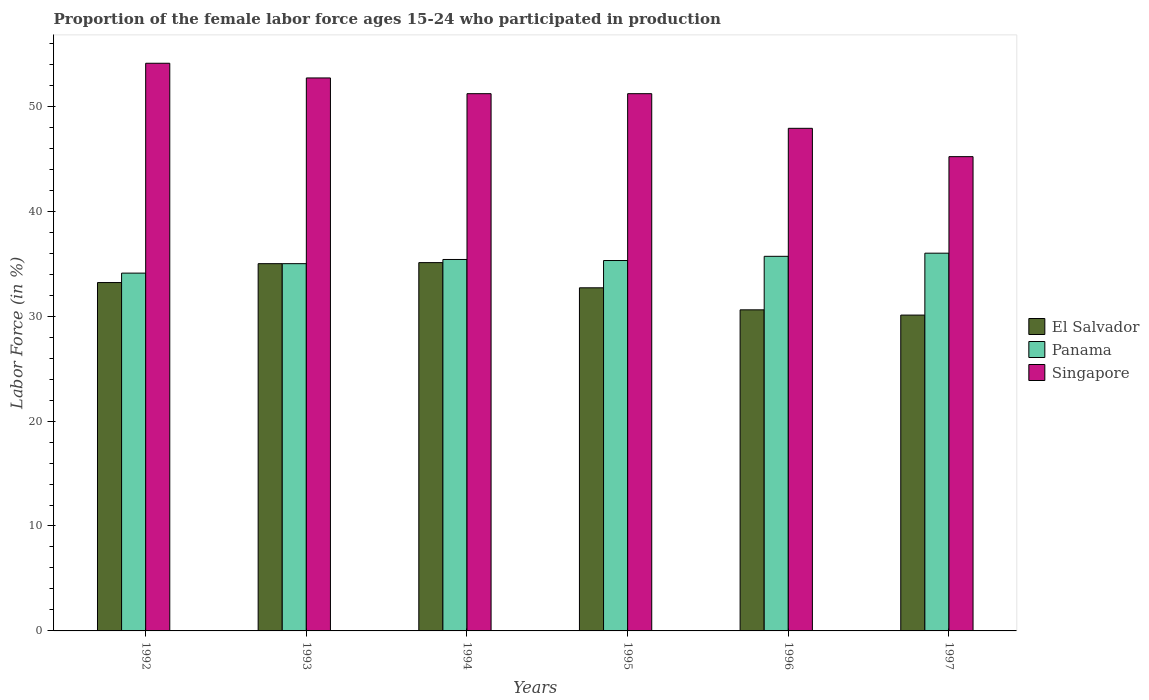How many groups of bars are there?
Keep it short and to the point. 6. How many bars are there on the 3rd tick from the left?
Provide a short and direct response. 3. How many bars are there on the 4th tick from the right?
Make the answer very short. 3. What is the label of the 3rd group of bars from the left?
Offer a very short reply. 1994. In how many cases, is the number of bars for a given year not equal to the number of legend labels?
Give a very brief answer. 0. What is the proportion of the female labor force who participated in production in Panama in 1997?
Your answer should be compact. 36. Across all years, what is the minimum proportion of the female labor force who participated in production in Singapore?
Offer a very short reply. 45.2. In which year was the proportion of the female labor force who participated in production in El Salvador maximum?
Offer a terse response. 1994. What is the total proportion of the female labor force who participated in production in El Salvador in the graph?
Give a very brief answer. 196.7. What is the difference between the proportion of the female labor force who participated in production in El Salvador in 1992 and that in 1994?
Offer a very short reply. -1.9. What is the difference between the proportion of the female labor force who participated in production in El Salvador in 1997 and the proportion of the female labor force who participated in production in Panama in 1996?
Provide a short and direct response. -5.6. What is the average proportion of the female labor force who participated in production in Singapore per year?
Offer a very short reply. 50.38. In the year 1995, what is the difference between the proportion of the female labor force who participated in production in Panama and proportion of the female labor force who participated in production in Singapore?
Your answer should be compact. -15.9. What is the ratio of the proportion of the female labor force who participated in production in El Salvador in 1992 to that in 1995?
Give a very brief answer. 1.02. Is the proportion of the female labor force who participated in production in El Salvador in 1994 less than that in 1995?
Provide a short and direct response. No. Is the difference between the proportion of the female labor force who participated in production in Panama in 1995 and 1997 greater than the difference between the proportion of the female labor force who participated in production in Singapore in 1995 and 1997?
Keep it short and to the point. No. What is the difference between the highest and the second highest proportion of the female labor force who participated in production in El Salvador?
Give a very brief answer. 0.1. What is the difference between the highest and the lowest proportion of the female labor force who participated in production in Singapore?
Your answer should be very brief. 8.9. What does the 2nd bar from the left in 1992 represents?
Your answer should be compact. Panama. What does the 2nd bar from the right in 1992 represents?
Provide a succinct answer. Panama. Are all the bars in the graph horizontal?
Your answer should be compact. No. Does the graph contain grids?
Give a very brief answer. No. Where does the legend appear in the graph?
Your answer should be compact. Center right. How many legend labels are there?
Provide a succinct answer. 3. What is the title of the graph?
Keep it short and to the point. Proportion of the female labor force ages 15-24 who participated in production. What is the label or title of the Y-axis?
Offer a very short reply. Labor Force (in %). What is the Labor Force (in %) in El Salvador in 1992?
Provide a succinct answer. 33.2. What is the Labor Force (in %) of Panama in 1992?
Give a very brief answer. 34.1. What is the Labor Force (in %) in Singapore in 1992?
Make the answer very short. 54.1. What is the Labor Force (in %) in El Salvador in 1993?
Give a very brief answer. 35. What is the Labor Force (in %) in Panama in 1993?
Give a very brief answer. 35. What is the Labor Force (in %) of Singapore in 1993?
Give a very brief answer. 52.7. What is the Labor Force (in %) of El Salvador in 1994?
Your response must be concise. 35.1. What is the Labor Force (in %) of Panama in 1994?
Provide a succinct answer. 35.4. What is the Labor Force (in %) in Singapore in 1994?
Keep it short and to the point. 51.2. What is the Labor Force (in %) in El Salvador in 1995?
Ensure brevity in your answer.  32.7. What is the Labor Force (in %) in Panama in 1995?
Offer a terse response. 35.3. What is the Labor Force (in %) in Singapore in 1995?
Your answer should be compact. 51.2. What is the Labor Force (in %) in El Salvador in 1996?
Give a very brief answer. 30.6. What is the Labor Force (in %) in Panama in 1996?
Make the answer very short. 35.7. What is the Labor Force (in %) in Singapore in 1996?
Your response must be concise. 47.9. What is the Labor Force (in %) in El Salvador in 1997?
Your answer should be compact. 30.1. What is the Labor Force (in %) of Panama in 1997?
Your response must be concise. 36. What is the Labor Force (in %) of Singapore in 1997?
Give a very brief answer. 45.2. Across all years, what is the maximum Labor Force (in %) in El Salvador?
Offer a very short reply. 35.1. Across all years, what is the maximum Labor Force (in %) in Panama?
Keep it short and to the point. 36. Across all years, what is the maximum Labor Force (in %) in Singapore?
Keep it short and to the point. 54.1. Across all years, what is the minimum Labor Force (in %) of El Salvador?
Your answer should be compact. 30.1. Across all years, what is the minimum Labor Force (in %) in Panama?
Ensure brevity in your answer.  34.1. Across all years, what is the minimum Labor Force (in %) in Singapore?
Your answer should be very brief. 45.2. What is the total Labor Force (in %) in El Salvador in the graph?
Make the answer very short. 196.7. What is the total Labor Force (in %) of Panama in the graph?
Keep it short and to the point. 211.5. What is the total Labor Force (in %) of Singapore in the graph?
Your response must be concise. 302.3. What is the difference between the Labor Force (in %) in Panama in 1992 and that in 1993?
Give a very brief answer. -0.9. What is the difference between the Labor Force (in %) in El Salvador in 1992 and that in 1994?
Give a very brief answer. -1.9. What is the difference between the Labor Force (in %) in Panama in 1992 and that in 1995?
Provide a succinct answer. -1.2. What is the difference between the Labor Force (in %) of Singapore in 1992 and that in 1996?
Keep it short and to the point. 6.2. What is the difference between the Labor Force (in %) of El Salvador in 1992 and that in 1997?
Give a very brief answer. 3.1. What is the difference between the Labor Force (in %) in Panama in 1992 and that in 1997?
Provide a short and direct response. -1.9. What is the difference between the Labor Force (in %) in Panama in 1993 and that in 1994?
Ensure brevity in your answer.  -0.4. What is the difference between the Labor Force (in %) in El Salvador in 1993 and that in 1995?
Offer a terse response. 2.3. What is the difference between the Labor Force (in %) of Panama in 1993 and that in 1995?
Ensure brevity in your answer.  -0.3. What is the difference between the Labor Force (in %) in El Salvador in 1993 and that in 1996?
Provide a short and direct response. 4.4. What is the difference between the Labor Force (in %) in Panama in 1993 and that in 1996?
Keep it short and to the point. -0.7. What is the difference between the Labor Force (in %) in Singapore in 1993 and that in 1996?
Your response must be concise. 4.8. What is the difference between the Labor Force (in %) of El Salvador in 1993 and that in 1997?
Offer a terse response. 4.9. What is the difference between the Labor Force (in %) of Panama in 1993 and that in 1997?
Provide a succinct answer. -1. What is the difference between the Labor Force (in %) of El Salvador in 1994 and that in 1995?
Offer a very short reply. 2.4. What is the difference between the Labor Force (in %) of Singapore in 1994 and that in 1996?
Provide a succinct answer. 3.3. What is the difference between the Labor Force (in %) of Singapore in 1994 and that in 1997?
Ensure brevity in your answer.  6. What is the difference between the Labor Force (in %) of El Salvador in 1995 and that in 1996?
Your response must be concise. 2.1. What is the difference between the Labor Force (in %) of Singapore in 1995 and that in 1996?
Ensure brevity in your answer.  3.3. What is the difference between the Labor Force (in %) in El Salvador in 1995 and that in 1997?
Keep it short and to the point. 2.6. What is the difference between the Labor Force (in %) in Singapore in 1995 and that in 1997?
Ensure brevity in your answer.  6. What is the difference between the Labor Force (in %) in Panama in 1996 and that in 1997?
Your answer should be very brief. -0.3. What is the difference between the Labor Force (in %) in El Salvador in 1992 and the Labor Force (in %) in Panama in 1993?
Keep it short and to the point. -1.8. What is the difference between the Labor Force (in %) in El Salvador in 1992 and the Labor Force (in %) in Singapore in 1993?
Provide a short and direct response. -19.5. What is the difference between the Labor Force (in %) of Panama in 1992 and the Labor Force (in %) of Singapore in 1993?
Offer a terse response. -18.6. What is the difference between the Labor Force (in %) of Panama in 1992 and the Labor Force (in %) of Singapore in 1994?
Your response must be concise. -17.1. What is the difference between the Labor Force (in %) of El Salvador in 1992 and the Labor Force (in %) of Singapore in 1995?
Offer a very short reply. -18. What is the difference between the Labor Force (in %) in Panama in 1992 and the Labor Force (in %) in Singapore in 1995?
Offer a terse response. -17.1. What is the difference between the Labor Force (in %) in El Salvador in 1992 and the Labor Force (in %) in Singapore in 1996?
Offer a very short reply. -14.7. What is the difference between the Labor Force (in %) of El Salvador in 1992 and the Labor Force (in %) of Panama in 1997?
Provide a short and direct response. -2.8. What is the difference between the Labor Force (in %) in El Salvador in 1992 and the Labor Force (in %) in Singapore in 1997?
Make the answer very short. -12. What is the difference between the Labor Force (in %) in Panama in 1992 and the Labor Force (in %) in Singapore in 1997?
Offer a terse response. -11.1. What is the difference between the Labor Force (in %) of El Salvador in 1993 and the Labor Force (in %) of Singapore in 1994?
Your response must be concise. -16.2. What is the difference between the Labor Force (in %) in Panama in 1993 and the Labor Force (in %) in Singapore in 1994?
Provide a succinct answer. -16.2. What is the difference between the Labor Force (in %) of El Salvador in 1993 and the Labor Force (in %) of Panama in 1995?
Give a very brief answer. -0.3. What is the difference between the Labor Force (in %) in El Salvador in 1993 and the Labor Force (in %) in Singapore in 1995?
Offer a very short reply. -16.2. What is the difference between the Labor Force (in %) in Panama in 1993 and the Labor Force (in %) in Singapore in 1995?
Offer a very short reply. -16.2. What is the difference between the Labor Force (in %) in Panama in 1993 and the Labor Force (in %) in Singapore in 1996?
Your answer should be very brief. -12.9. What is the difference between the Labor Force (in %) in El Salvador in 1993 and the Labor Force (in %) in Singapore in 1997?
Give a very brief answer. -10.2. What is the difference between the Labor Force (in %) in El Salvador in 1994 and the Labor Force (in %) in Singapore in 1995?
Your response must be concise. -16.1. What is the difference between the Labor Force (in %) in Panama in 1994 and the Labor Force (in %) in Singapore in 1995?
Provide a short and direct response. -15.8. What is the difference between the Labor Force (in %) in El Salvador in 1994 and the Labor Force (in %) in Panama in 1996?
Keep it short and to the point. -0.6. What is the difference between the Labor Force (in %) in Panama in 1994 and the Labor Force (in %) in Singapore in 1996?
Make the answer very short. -12.5. What is the difference between the Labor Force (in %) in El Salvador in 1994 and the Labor Force (in %) in Singapore in 1997?
Give a very brief answer. -10.1. What is the difference between the Labor Force (in %) of El Salvador in 1995 and the Labor Force (in %) of Panama in 1996?
Offer a terse response. -3. What is the difference between the Labor Force (in %) in El Salvador in 1995 and the Labor Force (in %) in Singapore in 1996?
Give a very brief answer. -15.2. What is the difference between the Labor Force (in %) of El Salvador in 1995 and the Labor Force (in %) of Singapore in 1997?
Provide a short and direct response. -12.5. What is the difference between the Labor Force (in %) of Panama in 1995 and the Labor Force (in %) of Singapore in 1997?
Offer a terse response. -9.9. What is the difference between the Labor Force (in %) of El Salvador in 1996 and the Labor Force (in %) of Panama in 1997?
Provide a short and direct response. -5.4. What is the difference between the Labor Force (in %) in El Salvador in 1996 and the Labor Force (in %) in Singapore in 1997?
Provide a short and direct response. -14.6. What is the average Labor Force (in %) in El Salvador per year?
Offer a terse response. 32.78. What is the average Labor Force (in %) of Panama per year?
Your answer should be compact. 35.25. What is the average Labor Force (in %) of Singapore per year?
Make the answer very short. 50.38. In the year 1992, what is the difference between the Labor Force (in %) in El Salvador and Labor Force (in %) in Singapore?
Your response must be concise. -20.9. In the year 1992, what is the difference between the Labor Force (in %) of Panama and Labor Force (in %) of Singapore?
Provide a short and direct response. -20. In the year 1993, what is the difference between the Labor Force (in %) in El Salvador and Labor Force (in %) in Panama?
Offer a very short reply. 0. In the year 1993, what is the difference between the Labor Force (in %) of El Salvador and Labor Force (in %) of Singapore?
Make the answer very short. -17.7. In the year 1993, what is the difference between the Labor Force (in %) in Panama and Labor Force (in %) in Singapore?
Offer a terse response. -17.7. In the year 1994, what is the difference between the Labor Force (in %) of El Salvador and Labor Force (in %) of Panama?
Your response must be concise. -0.3. In the year 1994, what is the difference between the Labor Force (in %) in El Salvador and Labor Force (in %) in Singapore?
Provide a succinct answer. -16.1. In the year 1994, what is the difference between the Labor Force (in %) in Panama and Labor Force (in %) in Singapore?
Your answer should be very brief. -15.8. In the year 1995, what is the difference between the Labor Force (in %) in El Salvador and Labor Force (in %) in Panama?
Keep it short and to the point. -2.6. In the year 1995, what is the difference between the Labor Force (in %) in El Salvador and Labor Force (in %) in Singapore?
Your answer should be compact. -18.5. In the year 1995, what is the difference between the Labor Force (in %) in Panama and Labor Force (in %) in Singapore?
Keep it short and to the point. -15.9. In the year 1996, what is the difference between the Labor Force (in %) of El Salvador and Labor Force (in %) of Panama?
Offer a terse response. -5.1. In the year 1996, what is the difference between the Labor Force (in %) of El Salvador and Labor Force (in %) of Singapore?
Ensure brevity in your answer.  -17.3. In the year 1996, what is the difference between the Labor Force (in %) of Panama and Labor Force (in %) of Singapore?
Give a very brief answer. -12.2. In the year 1997, what is the difference between the Labor Force (in %) of El Salvador and Labor Force (in %) of Panama?
Give a very brief answer. -5.9. In the year 1997, what is the difference between the Labor Force (in %) of El Salvador and Labor Force (in %) of Singapore?
Your response must be concise. -15.1. In the year 1997, what is the difference between the Labor Force (in %) of Panama and Labor Force (in %) of Singapore?
Offer a very short reply. -9.2. What is the ratio of the Labor Force (in %) of El Salvador in 1992 to that in 1993?
Your answer should be very brief. 0.95. What is the ratio of the Labor Force (in %) of Panama in 1992 to that in 1993?
Give a very brief answer. 0.97. What is the ratio of the Labor Force (in %) of Singapore in 1992 to that in 1993?
Provide a short and direct response. 1.03. What is the ratio of the Labor Force (in %) of El Salvador in 1992 to that in 1994?
Ensure brevity in your answer.  0.95. What is the ratio of the Labor Force (in %) in Panama in 1992 to that in 1994?
Provide a short and direct response. 0.96. What is the ratio of the Labor Force (in %) in Singapore in 1992 to that in 1994?
Ensure brevity in your answer.  1.06. What is the ratio of the Labor Force (in %) of El Salvador in 1992 to that in 1995?
Your answer should be very brief. 1.02. What is the ratio of the Labor Force (in %) of Panama in 1992 to that in 1995?
Your answer should be compact. 0.97. What is the ratio of the Labor Force (in %) in Singapore in 1992 to that in 1995?
Offer a very short reply. 1.06. What is the ratio of the Labor Force (in %) of El Salvador in 1992 to that in 1996?
Ensure brevity in your answer.  1.08. What is the ratio of the Labor Force (in %) of Panama in 1992 to that in 1996?
Your answer should be very brief. 0.96. What is the ratio of the Labor Force (in %) in Singapore in 1992 to that in 1996?
Keep it short and to the point. 1.13. What is the ratio of the Labor Force (in %) of El Salvador in 1992 to that in 1997?
Keep it short and to the point. 1.1. What is the ratio of the Labor Force (in %) of Panama in 1992 to that in 1997?
Your answer should be very brief. 0.95. What is the ratio of the Labor Force (in %) in Singapore in 1992 to that in 1997?
Your answer should be very brief. 1.2. What is the ratio of the Labor Force (in %) of El Salvador in 1993 to that in 1994?
Your response must be concise. 1. What is the ratio of the Labor Force (in %) of Panama in 1993 to that in 1994?
Provide a short and direct response. 0.99. What is the ratio of the Labor Force (in %) in Singapore in 1993 to that in 1994?
Your answer should be very brief. 1.03. What is the ratio of the Labor Force (in %) in El Salvador in 1993 to that in 1995?
Your answer should be compact. 1.07. What is the ratio of the Labor Force (in %) in Singapore in 1993 to that in 1995?
Offer a very short reply. 1.03. What is the ratio of the Labor Force (in %) of El Salvador in 1993 to that in 1996?
Make the answer very short. 1.14. What is the ratio of the Labor Force (in %) of Panama in 1993 to that in 1996?
Give a very brief answer. 0.98. What is the ratio of the Labor Force (in %) of Singapore in 1993 to that in 1996?
Make the answer very short. 1.1. What is the ratio of the Labor Force (in %) in El Salvador in 1993 to that in 1997?
Offer a terse response. 1.16. What is the ratio of the Labor Force (in %) in Panama in 1993 to that in 1997?
Your response must be concise. 0.97. What is the ratio of the Labor Force (in %) in Singapore in 1993 to that in 1997?
Your answer should be very brief. 1.17. What is the ratio of the Labor Force (in %) of El Salvador in 1994 to that in 1995?
Provide a succinct answer. 1.07. What is the ratio of the Labor Force (in %) in Singapore in 1994 to that in 1995?
Make the answer very short. 1. What is the ratio of the Labor Force (in %) of El Salvador in 1994 to that in 1996?
Your answer should be compact. 1.15. What is the ratio of the Labor Force (in %) in Panama in 1994 to that in 1996?
Provide a short and direct response. 0.99. What is the ratio of the Labor Force (in %) in Singapore in 1994 to that in 1996?
Keep it short and to the point. 1.07. What is the ratio of the Labor Force (in %) in El Salvador in 1994 to that in 1997?
Offer a very short reply. 1.17. What is the ratio of the Labor Force (in %) of Panama in 1994 to that in 1997?
Your answer should be very brief. 0.98. What is the ratio of the Labor Force (in %) of Singapore in 1994 to that in 1997?
Make the answer very short. 1.13. What is the ratio of the Labor Force (in %) in El Salvador in 1995 to that in 1996?
Your answer should be very brief. 1.07. What is the ratio of the Labor Force (in %) in Panama in 1995 to that in 1996?
Ensure brevity in your answer.  0.99. What is the ratio of the Labor Force (in %) of Singapore in 1995 to that in 1996?
Provide a short and direct response. 1.07. What is the ratio of the Labor Force (in %) in El Salvador in 1995 to that in 1997?
Offer a terse response. 1.09. What is the ratio of the Labor Force (in %) in Panama in 1995 to that in 1997?
Your answer should be very brief. 0.98. What is the ratio of the Labor Force (in %) in Singapore in 1995 to that in 1997?
Your response must be concise. 1.13. What is the ratio of the Labor Force (in %) of El Salvador in 1996 to that in 1997?
Give a very brief answer. 1.02. What is the ratio of the Labor Force (in %) in Panama in 1996 to that in 1997?
Keep it short and to the point. 0.99. What is the ratio of the Labor Force (in %) in Singapore in 1996 to that in 1997?
Make the answer very short. 1.06. What is the difference between the highest and the second highest Labor Force (in %) in El Salvador?
Provide a succinct answer. 0.1. What is the difference between the highest and the second highest Labor Force (in %) in Panama?
Provide a short and direct response. 0.3. What is the difference between the highest and the lowest Labor Force (in %) of Panama?
Provide a short and direct response. 1.9. What is the difference between the highest and the lowest Labor Force (in %) of Singapore?
Provide a succinct answer. 8.9. 